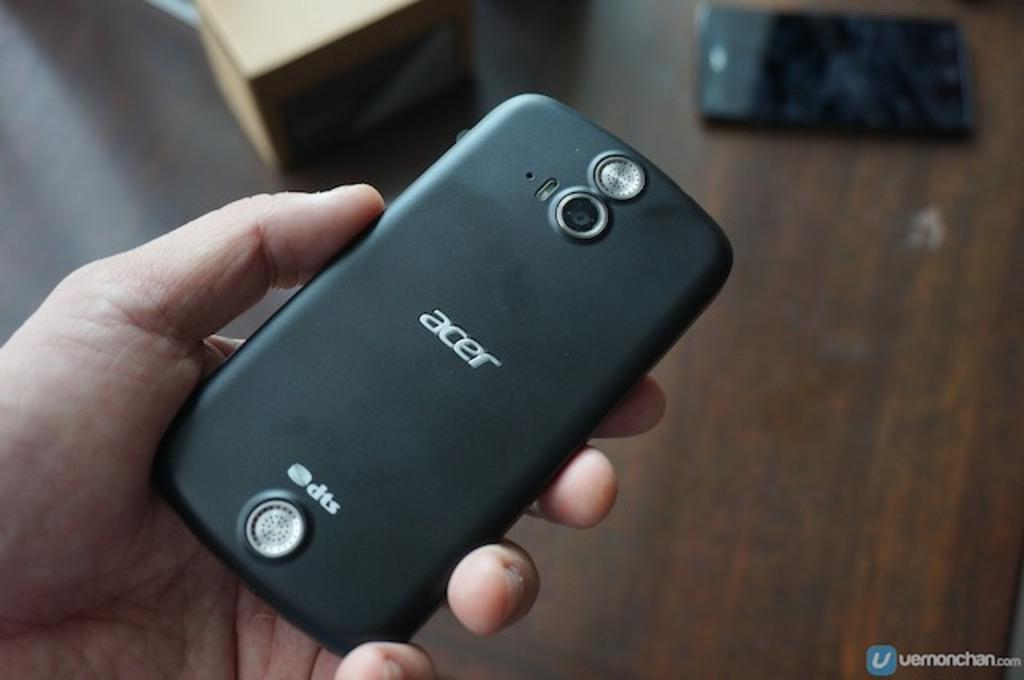<image>
Give a short and clear explanation of the subsequent image. hand holding small black acer phone above table with another phone on it 